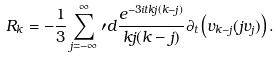<formula> <loc_0><loc_0><loc_500><loc_500>R _ { k } = - \frac { 1 } { 3 } \sum _ { j = - \infty } ^ { \infty } \prime d \frac { e ^ { - 3 i t k j ( k - j ) } } { k j ( k - j ) } \partial _ { t } \left ( v _ { k - j } ( j v _ { j } ) \right ) .</formula> 